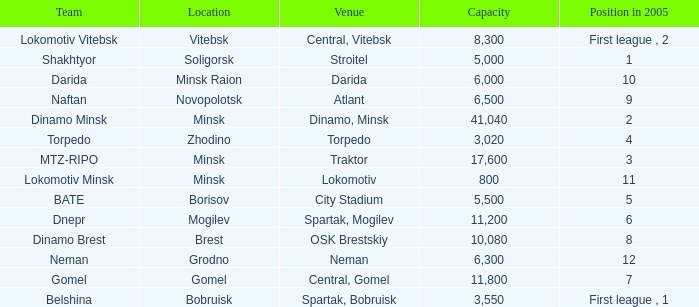Give me the full table as a dictionary. {'header': ['Team', 'Location', 'Venue', 'Capacity', 'Position in 2005'], 'rows': [['Lokomotiv Vitebsk', 'Vitebsk', 'Central, Vitebsk', '8,300', 'First league , 2'], ['Shakhtyor', 'Soligorsk', 'Stroitel', '5,000', '1'], ['Darida', 'Minsk Raion', 'Darida', '6,000', '10'], ['Naftan', 'Novopolotsk', 'Atlant', '6,500', '9'], ['Dinamo Minsk', 'Minsk', 'Dinamo, Minsk', '41,040', '2'], ['Torpedo', 'Zhodino', 'Torpedo', '3,020', '4'], ['MTZ-RIPO', 'Minsk', 'Traktor', '17,600', '3'], ['Lokomotiv Minsk', 'Minsk', 'Lokomotiv', '800', '11'], ['BATE', 'Borisov', 'City Stadium', '5,500', '5'], ['Dnepr', 'Mogilev', 'Spartak, Mogilev', '11,200', '6'], ['Dinamo Brest', 'Brest', 'OSK Brestskiy', '10,080', '8'], ['Neman', 'Grodno', 'Neman', '6,300', '12'], ['Gomel', 'Gomel', 'Central, Gomel', '11,800', '7'], ['Belshina', 'Bobruisk', 'Spartak, Bobruisk', '3,550', 'First league , 1']]} Can you tell me the Venue that has the Position in 2005 of 8? OSK Brestskiy. 